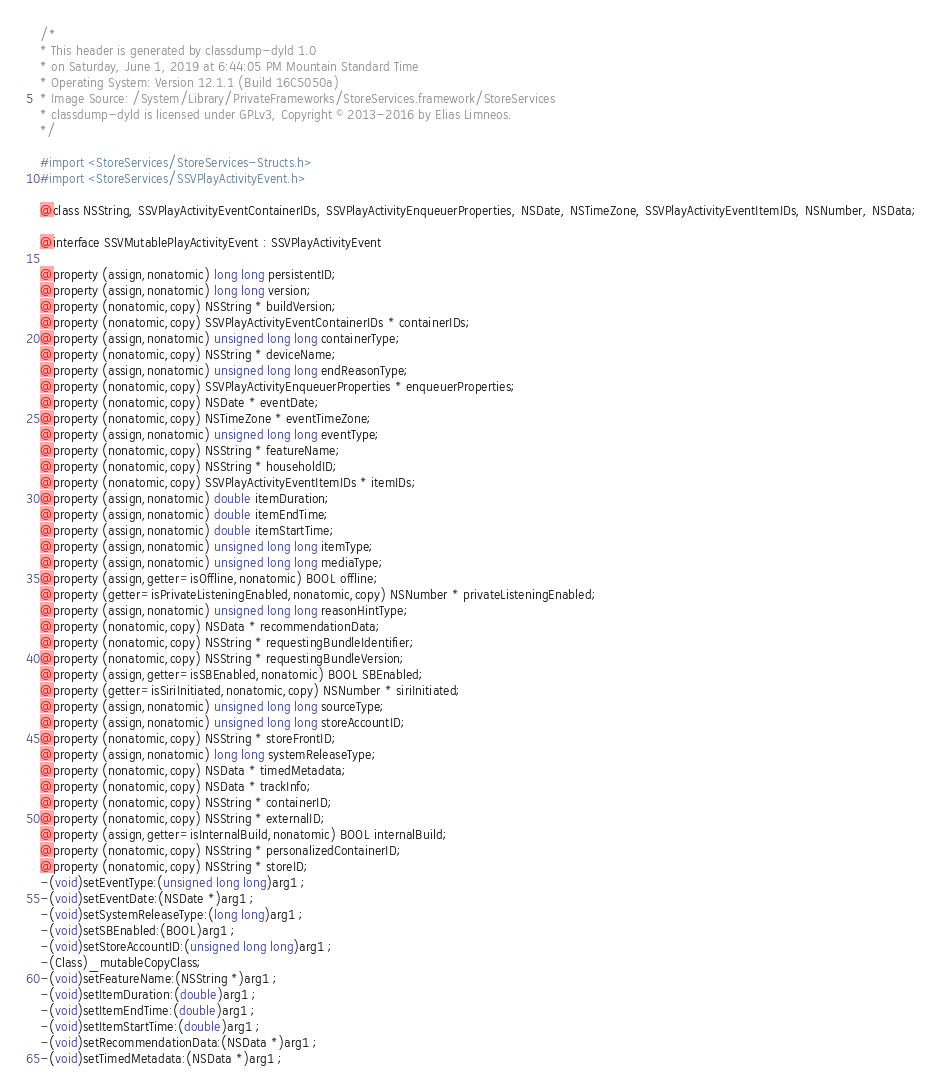<code> <loc_0><loc_0><loc_500><loc_500><_C_>/*
* This header is generated by classdump-dyld 1.0
* on Saturday, June 1, 2019 at 6:44:05 PM Mountain Standard Time
* Operating System: Version 12.1.1 (Build 16C5050a)
* Image Source: /System/Library/PrivateFrameworks/StoreServices.framework/StoreServices
* classdump-dyld is licensed under GPLv3, Copyright © 2013-2016 by Elias Limneos.
*/

#import <StoreServices/StoreServices-Structs.h>
#import <StoreServices/SSVPlayActivityEvent.h>

@class NSString, SSVPlayActivityEventContainerIDs, SSVPlayActivityEnqueuerProperties, NSDate, NSTimeZone, SSVPlayActivityEventItemIDs, NSNumber, NSData;

@interface SSVMutablePlayActivityEvent : SSVPlayActivityEvent

@property (assign,nonatomic) long long persistentID; 
@property (assign,nonatomic) long long version; 
@property (nonatomic,copy) NSString * buildVersion; 
@property (nonatomic,copy) SSVPlayActivityEventContainerIDs * containerIDs; 
@property (assign,nonatomic) unsigned long long containerType; 
@property (nonatomic,copy) NSString * deviceName; 
@property (assign,nonatomic) unsigned long long endReasonType; 
@property (nonatomic,copy) SSVPlayActivityEnqueuerProperties * enqueuerProperties; 
@property (nonatomic,copy) NSDate * eventDate; 
@property (nonatomic,copy) NSTimeZone * eventTimeZone; 
@property (assign,nonatomic) unsigned long long eventType; 
@property (nonatomic,copy) NSString * featureName; 
@property (nonatomic,copy) NSString * householdID; 
@property (nonatomic,copy) SSVPlayActivityEventItemIDs * itemIDs; 
@property (assign,nonatomic) double itemDuration; 
@property (assign,nonatomic) double itemEndTime; 
@property (assign,nonatomic) double itemStartTime; 
@property (assign,nonatomic) unsigned long long itemType; 
@property (assign,nonatomic) unsigned long long mediaType; 
@property (assign,getter=isOffline,nonatomic) BOOL offline; 
@property (getter=isPrivateListeningEnabled,nonatomic,copy) NSNumber * privateListeningEnabled; 
@property (assign,nonatomic) unsigned long long reasonHintType; 
@property (nonatomic,copy) NSData * recommendationData; 
@property (nonatomic,copy) NSString * requestingBundleIdentifier; 
@property (nonatomic,copy) NSString * requestingBundleVersion; 
@property (assign,getter=isSBEnabled,nonatomic) BOOL SBEnabled; 
@property (getter=isSiriInitiated,nonatomic,copy) NSNumber * siriInitiated; 
@property (assign,nonatomic) unsigned long long sourceType; 
@property (assign,nonatomic) unsigned long long storeAccountID; 
@property (nonatomic,copy) NSString * storeFrontID; 
@property (assign,nonatomic) long long systemReleaseType; 
@property (nonatomic,copy) NSData * timedMetadata; 
@property (nonatomic,copy) NSData * trackInfo; 
@property (nonatomic,copy) NSString * containerID; 
@property (nonatomic,copy) NSString * externalID; 
@property (assign,getter=isInternalBuild,nonatomic) BOOL internalBuild; 
@property (nonatomic,copy) NSString * personalizedContainerID; 
@property (nonatomic,copy) NSString * storeID; 
-(void)setEventType:(unsigned long long)arg1 ;
-(void)setEventDate:(NSDate *)arg1 ;
-(void)setSystemReleaseType:(long long)arg1 ;
-(void)setSBEnabled:(BOOL)arg1 ;
-(void)setStoreAccountID:(unsigned long long)arg1 ;
-(Class)_mutableCopyClass;
-(void)setFeatureName:(NSString *)arg1 ;
-(void)setItemDuration:(double)arg1 ;
-(void)setItemEndTime:(double)arg1 ;
-(void)setItemStartTime:(double)arg1 ;
-(void)setRecommendationData:(NSData *)arg1 ;
-(void)setTimedMetadata:(NSData *)arg1 ;</code> 